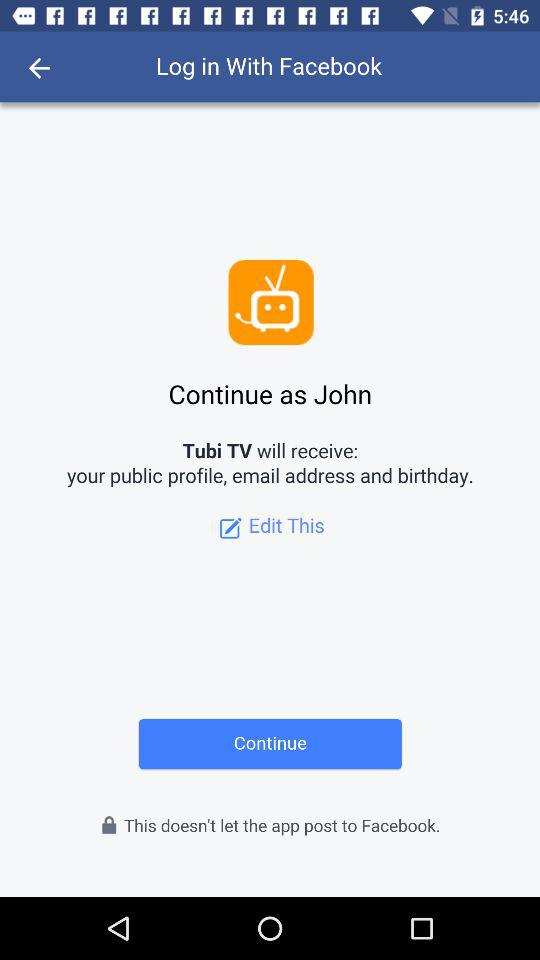How many profile details will Tubi TV receive?
Answer the question using a single word or phrase. 3 